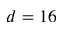Convert formula to latex. <formula><loc_0><loc_0><loc_500><loc_500>d = 1 6</formula> 